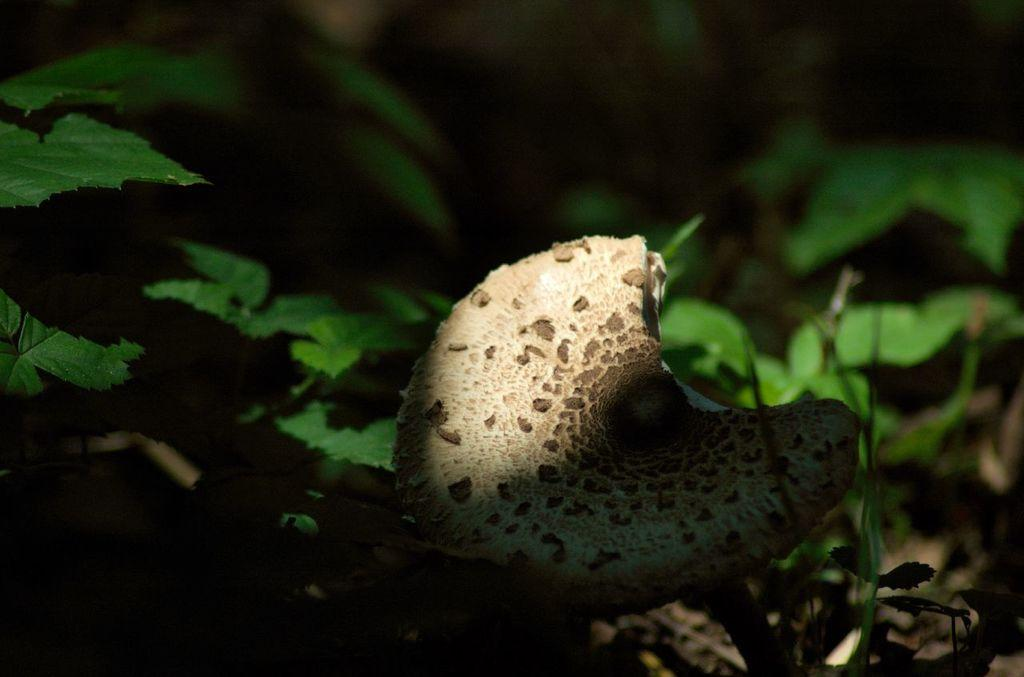What is the main subject of the picture? The main subject of the picture is a mushroom. What can be seen around the mushroom? There are leaves around the mushroom. How would you describe the overall appearance of the image? The backdrop of the image is dark. What type of music is being played by the mushroom in the image? There is no indication of music or any sound in the image, as it features a mushroom and leaves. 